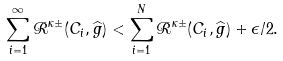<formula> <loc_0><loc_0><loc_500><loc_500>\sum _ { i = 1 } ^ { \infty } \mathcal { R } ^ { \kappa \pm } ( C _ { i } , \widehat { g } ) < \sum _ { i = 1 } ^ { N } \mathcal { R } ^ { \kappa \pm } ( C _ { i } , \widehat { g } ) + \epsilon / 2 .</formula> 